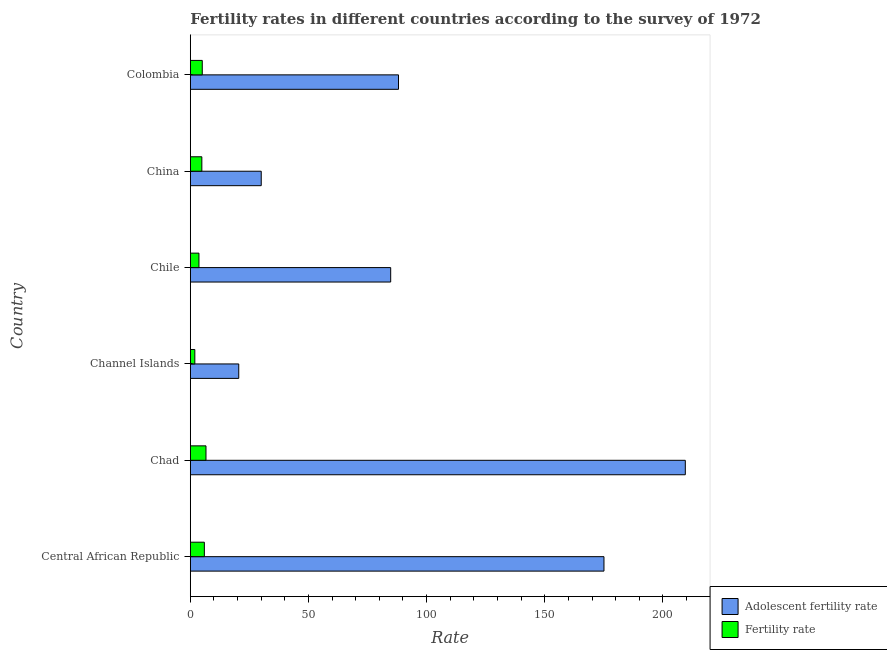Are the number of bars per tick equal to the number of legend labels?
Provide a succinct answer. Yes. What is the label of the 5th group of bars from the top?
Your answer should be very brief. Chad. In how many cases, is the number of bars for a given country not equal to the number of legend labels?
Your answer should be compact. 0. What is the fertility rate in Chile?
Make the answer very short. 3.67. Across all countries, what is the maximum fertility rate?
Your answer should be compact. 6.64. Across all countries, what is the minimum fertility rate?
Make the answer very short. 1.92. In which country was the adolescent fertility rate maximum?
Keep it short and to the point. Chad. In which country was the adolescent fertility rate minimum?
Your answer should be very brief. Channel Islands. What is the total fertility rate in the graph?
Your answer should be compact. 28.13. What is the difference between the adolescent fertility rate in Channel Islands and that in Chile?
Your answer should be compact. -64.3. What is the difference between the fertility rate in Colombia and the adolescent fertility rate in Chad?
Offer a very short reply. -204.4. What is the average adolescent fertility rate per country?
Your response must be concise. 101.32. What is the difference between the adolescent fertility rate and fertility rate in China?
Offer a terse response. 25.13. In how many countries, is the fertility rate greater than 50 ?
Provide a succinct answer. 0. What is the ratio of the adolescent fertility rate in Central African Republic to that in Colombia?
Provide a short and direct response. 1.99. Is the fertility rate in Central African Republic less than that in Channel Islands?
Ensure brevity in your answer.  No. What is the difference between the highest and the second highest adolescent fertility rate?
Provide a short and direct response. 34.42. What is the difference between the highest and the lowest fertility rate?
Your response must be concise. 4.72. In how many countries, is the adolescent fertility rate greater than the average adolescent fertility rate taken over all countries?
Ensure brevity in your answer.  2. Is the sum of the fertility rate in Channel Islands and Chile greater than the maximum adolescent fertility rate across all countries?
Your answer should be compact. No. What does the 2nd bar from the top in Chile represents?
Your answer should be compact. Adolescent fertility rate. What does the 1st bar from the bottom in Colombia represents?
Make the answer very short. Adolescent fertility rate. Are all the bars in the graph horizontal?
Provide a short and direct response. Yes. Are the values on the major ticks of X-axis written in scientific E-notation?
Give a very brief answer. No. Where does the legend appear in the graph?
Your answer should be very brief. Bottom right. What is the title of the graph?
Ensure brevity in your answer.  Fertility rates in different countries according to the survey of 1972. Does "GDP at market prices" appear as one of the legend labels in the graph?
Give a very brief answer. No. What is the label or title of the X-axis?
Your answer should be compact. Rate. What is the label or title of the Y-axis?
Keep it short and to the point. Country. What is the Rate in Adolescent fertility rate in Central African Republic?
Keep it short and to the point. 175.05. What is the Rate of Fertility rate in Central African Republic?
Make the answer very short. 5.95. What is the Rate of Adolescent fertility rate in Chad?
Provide a short and direct response. 209.47. What is the Rate of Fertility rate in Chad?
Provide a succinct answer. 6.64. What is the Rate of Adolescent fertility rate in Channel Islands?
Ensure brevity in your answer.  20.5. What is the Rate in Fertility rate in Channel Islands?
Provide a succinct answer. 1.92. What is the Rate of Adolescent fertility rate in Chile?
Your answer should be very brief. 84.8. What is the Rate of Fertility rate in Chile?
Give a very brief answer. 3.67. What is the Rate in Adolescent fertility rate in China?
Offer a very short reply. 30.02. What is the Rate in Fertility rate in China?
Your answer should be compact. 4.89. What is the Rate of Adolescent fertility rate in Colombia?
Provide a succinct answer. 88.1. What is the Rate of Fertility rate in Colombia?
Your answer should be very brief. 5.07. Across all countries, what is the maximum Rate in Adolescent fertility rate?
Offer a terse response. 209.47. Across all countries, what is the maximum Rate in Fertility rate?
Your answer should be very brief. 6.64. Across all countries, what is the minimum Rate in Adolescent fertility rate?
Give a very brief answer. 20.5. Across all countries, what is the minimum Rate of Fertility rate?
Provide a succinct answer. 1.92. What is the total Rate in Adolescent fertility rate in the graph?
Provide a short and direct response. 607.94. What is the total Rate in Fertility rate in the graph?
Ensure brevity in your answer.  28.13. What is the difference between the Rate of Adolescent fertility rate in Central African Republic and that in Chad?
Make the answer very short. -34.42. What is the difference between the Rate of Fertility rate in Central African Republic and that in Chad?
Ensure brevity in your answer.  -0.68. What is the difference between the Rate of Adolescent fertility rate in Central African Republic and that in Channel Islands?
Provide a short and direct response. 154.55. What is the difference between the Rate in Fertility rate in Central African Republic and that in Channel Islands?
Ensure brevity in your answer.  4.04. What is the difference between the Rate of Adolescent fertility rate in Central African Republic and that in Chile?
Ensure brevity in your answer.  90.25. What is the difference between the Rate of Fertility rate in Central African Republic and that in Chile?
Offer a terse response. 2.29. What is the difference between the Rate in Adolescent fertility rate in Central African Republic and that in China?
Provide a succinct answer. 145.03. What is the difference between the Rate in Fertility rate in Central African Republic and that in China?
Make the answer very short. 1.07. What is the difference between the Rate in Adolescent fertility rate in Central African Republic and that in Colombia?
Provide a short and direct response. 86.95. What is the difference between the Rate in Fertility rate in Central African Republic and that in Colombia?
Offer a terse response. 0.89. What is the difference between the Rate of Adolescent fertility rate in Chad and that in Channel Islands?
Your response must be concise. 188.97. What is the difference between the Rate in Fertility rate in Chad and that in Channel Islands?
Your response must be concise. 4.72. What is the difference between the Rate in Adolescent fertility rate in Chad and that in Chile?
Offer a terse response. 124.67. What is the difference between the Rate in Fertility rate in Chad and that in Chile?
Keep it short and to the point. 2.97. What is the difference between the Rate in Adolescent fertility rate in Chad and that in China?
Offer a very short reply. 179.45. What is the difference between the Rate of Fertility rate in Chad and that in China?
Your response must be concise. 1.75. What is the difference between the Rate of Adolescent fertility rate in Chad and that in Colombia?
Your response must be concise. 121.37. What is the difference between the Rate of Fertility rate in Chad and that in Colombia?
Offer a terse response. 1.57. What is the difference between the Rate of Adolescent fertility rate in Channel Islands and that in Chile?
Your answer should be very brief. -64.3. What is the difference between the Rate in Fertility rate in Channel Islands and that in Chile?
Your response must be concise. -1.75. What is the difference between the Rate of Adolescent fertility rate in Channel Islands and that in China?
Provide a short and direct response. -9.52. What is the difference between the Rate of Fertility rate in Channel Islands and that in China?
Keep it short and to the point. -2.97. What is the difference between the Rate in Adolescent fertility rate in Channel Islands and that in Colombia?
Ensure brevity in your answer.  -67.6. What is the difference between the Rate of Fertility rate in Channel Islands and that in Colombia?
Ensure brevity in your answer.  -3.15. What is the difference between the Rate in Adolescent fertility rate in Chile and that in China?
Provide a succinct answer. 54.78. What is the difference between the Rate of Fertility rate in Chile and that in China?
Your response must be concise. -1.22. What is the difference between the Rate of Adolescent fertility rate in Chile and that in Colombia?
Offer a very short reply. -3.3. What is the difference between the Rate in Fertility rate in Chile and that in Colombia?
Ensure brevity in your answer.  -1.4. What is the difference between the Rate of Adolescent fertility rate in China and that in Colombia?
Your answer should be compact. -58.08. What is the difference between the Rate of Fertility rate in China and that in Colombia?
Your answer should be compact. -0.18. What is the difference between the Rate of Adolescent fertility rate in Central African Republic and the Rate of Fertility rate in Chad?
Offer a terse response. 168.41. What is the difference between the Rate of Adolescent fertility rate in Central African Republic and the Rate of Fertility rate in Channel Islands?
Give a very brief answer. 173.13. What is the difference between the Rate of Adolescent fertility rate in Central African Republic and the Rate of Fertility rate in Chile?
Offer a terse response. 171.38. What is the difference between the Rate of Adolescent fertility rate in Central African Republic and the Rate of Fertility rate in China?
Give a very brief answer. 170.16. What is the difference between the Rate in Adolescent fertility rate in Central African Republic and the Rate in Fertility rate in Colombia?
Ensure brevity in your answer.  169.98. What is the difference between the Rate of Adolescent fertility rate in Chad and the Rate of Fertility rate in Channel Islands?
Ensure brevity in your answer.  207.55. What is the difference between the Rate of Adolescent fertility rate in Chad and the Rate of Fertility rate in Chile?
Your answer should be very brief. 205.8. What is the difference between the Rate of Adolescent fertility rate in Chad and the Rate of Fertility rate in China?
Give a very brief answer. 204.58. What is the difference between the Rate of Adolescent fertility rate in Chad and the Rate of Fertility rate in Colombia?
Provide a succinct answer. 204.4. What is the difference between the Rate of Adolescent fertility rate in Channel Islands and the Rate of Fertility rate in Chile?
Your response must be concise. 16.84. What is the difference between the Rate of Adolescent fertility rate in Channel Islands and the Rate of Fertility rate in China?
Give a very brief answer. 15.61. What is the difference between the Rate of Adolescent fertility rate in Channel Islands and the Rate of Fertility rate in Colombia?
Your answer should be compact. 15.43. What is the difference between the Rate of Adolescent fertility rate in Chile and the Rate of Fertility rate in China?
Keep it short and to the point. 79.91. What is the difference between the Rate in Adolescent fertility rate in Chile and the Rate in Fertility rate in Colombia?
Offer a very short reply. 79.73. What is the difference between the Rate in Adolescent fertility rate in China and the Rate in Fertility rate in Colombia?
Your answer should be compact. 24.95. What is the average Rate in Adolescent fertility rate per country?
Your answer should be very brief. 101.32. What is the average Rate of Fertility rate per country?
Give a very brief answer. 4.69. What is the difference between the Rate of Adolescent fertility rate and Rate of Fertility rate in Central African Republic?
Offer a very short reply. 169.1. What is the difference between the Rate of Adolescent fertility rate and Rate of Fertility rate in Chad?
Offer a very short reply. 202.83. What is the difference between the Rate in Adolescent fertility rate and Rate in Fertility rate in Channel Islands?
Offer a terse response. 18.58. What is the difference between the Rate in Adolescent fertility rate and Rate in Fertility rate in Chile?
Offer a very short reply. 81.13. What is the difference between the Rate of Adolescent fertility rate and Rate of Fertility rate in China?
Your answer should be very brief. 25.13. What is the difference between the Rate of Adolescent fertility rate and Rate of Fertility rate in Colombia?
Provide a short and direct response. 83.03. What is the ratio of the Rate in Adolescent fertility rate in Central African Republic to that in Chad?
Your answer should be very brief. 0.84. What is the ratio of the Rate in Fertility rate in Central African Republic to that in Chad?
Make the answer very short. 0.9. What is the ratio of the Rate in Adolescent fertility rate in Central African Republic to that in Channel Islands?
Your response must be concise. 8.54. What is the ratio of the Rate of Fertility rate in Central African Republic to that in Channel Islands?
Your response must be concise. 3.1. What is the ratio of the Rate of Adolescent fertility rate in Central African Republic to that in Chile?
Give a very brief answer. 2.06. What is the ratio of the Rate of Fertility rate in Central African Republic to that in Chile?
Make the answer very short. 1.62. What is the ratio of the Rate of Adolescent fertility rate in Central African Republic to that in China?
Give a very brief answer. 5.83. What is the ratio of the Rate in Fertility rate in Central African Republic to that in China?
Offer a terse response. 1.22. What is the ratio of the Rate in Adolescent fertility rate in Central African Republic to that in Colombia?
Provide a succinct answer. 1.99. What is the ratio of the Rate in Fertility rate in Central African Republic to that in Colombia?
Ensure brevity in your answer.  1.17. What is the ratio of the Rate in Adolescent fertility rate in Chad to that in Channel Islands?
Provide a succinct answer. 10.22. What is the ratio of the Rate in Fertility rate in Chad to that in Channel Islands?
Give a very brief answer. 3.46. What is the ratio of the Rate of Adolescent fertility rate in Chad to that in Chile?
Keep it short and to the point. 2.47. What is the ratio of the Rate in Fertility rate in Chad to that in Chile?
Make the answer very short. 1.81. What is the ratio of the Rate of Adolescent fertility rate in Chad to that in China?
Offer a terse response. 6.98. What is the ratio of the Rate of Fertility rate in Chad to that in China?
Provide a short and direct response. 1.36. What is the ratio of the Rate of Adolescent fertility rate in Chad to that in Colombia?
Your answer should be very brief. 2.38. What is the ratio of the Rate in Fertility rate in Chad to that in Colombia?
Your response must be concise. 1.31. What is the ratio of the Rate in Adolescent fertility rate in Channel Islands to that in Chile?
Provide a succinct answer. 0.24. What is the ratio of the Rate of Fertility rate in Channel Islands to that in Chile?
Offer a terse response. 0.52. What is the ratio of the Rate in Adolescent fertility rate in Channel Islands to that in China?
Offer a very short reply. 0.68. What is the ratio of the Rate in Fertility rate in Channel Islands to that in China?
Provide a succinct answer. 0.39. What is the ratio of the Rate in Adolescent fertility rate in Channel Islands to that in Colombia?
Ensure brevity in your answer.  0.23. What is the ratio of the Rate of Fertility rate in Channel Islands to that in Colombia?
Your response must be concise. 0.38. What is the ratio of the Rate of Adolescent fertility rate in Chile to that in China?
Ensure brevity in your answer.  2.82. What is the ratio of the Rate in Fertility rate in Chile to that in China?
Your response must be concise. 0.75. What is the ratio of the Rate of Adolescent fertility rate in Chile to that in Colombia?
Give a very brief answer. 0.96. What is the ratio of the Rate in Fertility rate in Chile to that in Colombia?
Make the answer very short. 0.72. What is the ratio of the Rate of Adolescent fertility rate in China to that in Colombia?
Your answer should be compact. 0.34. What is the ratio of the Rate of Fertility rate in China to that in Colombia?
Keep it short and to the point. 0.96. What is the difference between the highest and the second highest Rate of Adolescent fertility rate?
Your answer should be very brief. 34.42. What is the difference between the highest and the second highest Rate of Fertility rate?
Your response must be concise. 0.68. What is the difference between the highest and the lowest Rate of Adolescent fertility rate?
Keep it short and to the point. 188.97. What is the difference between the highest and the lowest Rate of Fertility rate?
Ensure brevity in your answer.  4.72. 